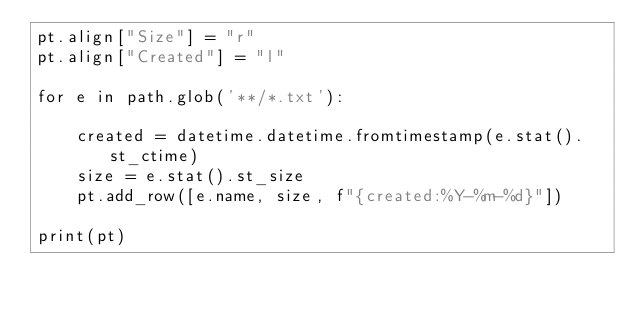<code> <loc_0><loc_0><loc_500><loc_500><_Python_>pt.align["Size"] = "r"
pt.align["Created"] = "l"

for e in path.glob('**/*.txt'):

    created = datetime.datetime.fromtimestamp(e.stat().st_ctime)
    size = e.stat().st_size
    pt.add_row([e.name, size, f"{created:%Y-%m-%d}"])
    
print(pt)
</code> 